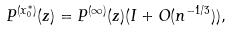Convert formula to latex. <formula><loc_0><loc_0><loc_500><loc_500>P ^ { ( x _ { 0 } ^ { * } ) } ( z ) = P ^ { ( \infty ) } ( z ) ( I + O ( n ^ { - 1 / 3 } ) ) ,</formula> 